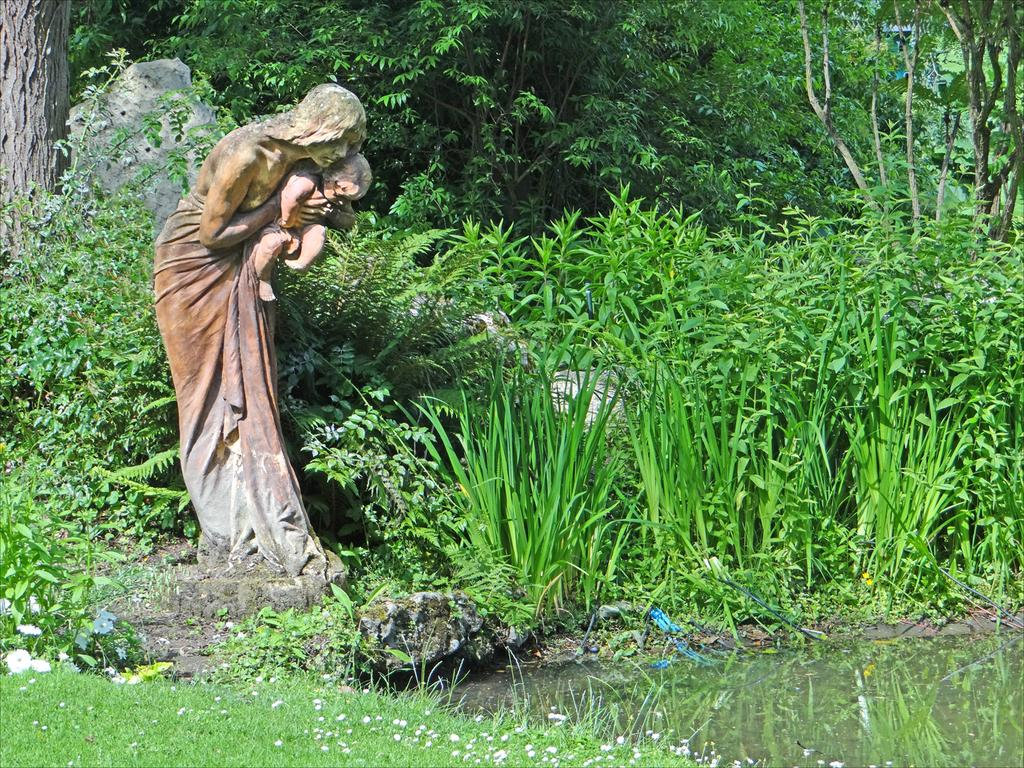What is the main subject in the image? There is a statue in the image. What can be seen in the background of the image? There are trees and plants in the background of the image. What type of vegetation is at the bottom of the image? There is grass at the bottom of the image. What is present on the right side of the image? There is water on the right side of the image. What type of silver suit can be seen on the statue in the image? There is no silver suit present on the statue in the image. The statue is not wearing any clothing, and there is no mention of silver in the provided facts. 